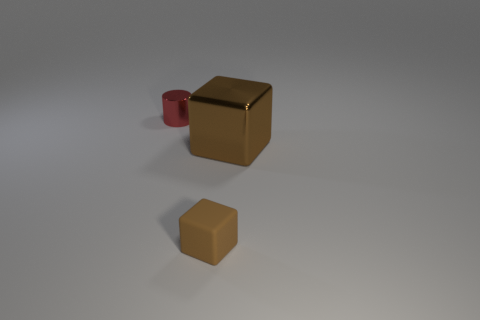Add 1 red matte cubes. How many objects exist? 4 Subtract all cubes. How many objects are left? 1 Add 3 small red shiny cylinders. How many small red shiny cylinders are left? 4 Add 2 tiny brown shiny cubes. How many tiny brown shiny cubes exist? 2 Subtract 0 red spheres. How many objects are left? 3 Subtract all small brown blocks. Subtract all big blocks. How many objects are left? 1 